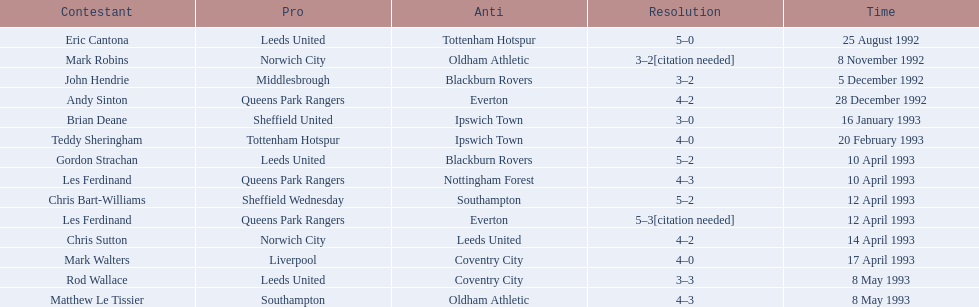How many players were for leeds united? 3. 